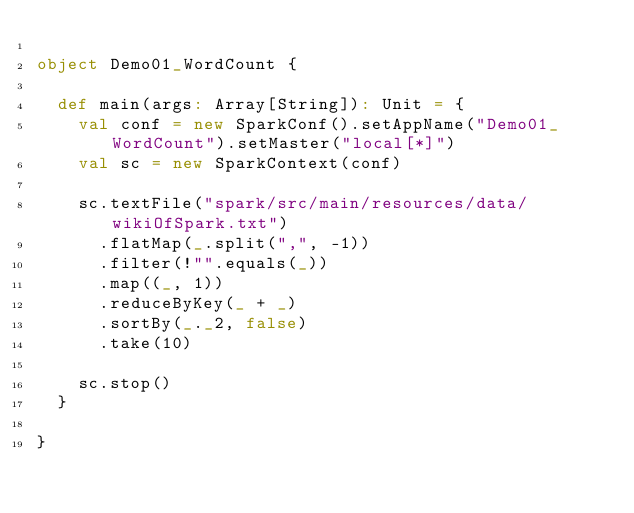<code> <loc_0><loc_0><loc_500><loc_500><_Scala_>
object Demo01_WordCount {

  def main(args: Array[String]): Unit = {
    val conf = new SparkConf().setAppName("Demo01_WordCount").setMaster("local[*]")
    val sc = new SparkContext(conf)

    sc.textFile("spark/src/main/resources/data/wikiOfSpark.txt")
      .flatMap(_.split(",", -1))
      .filter(!"".equals(_))
      .map((_, 1))
      .reduceByKey(_ + _)
      .sortBy(_._2, false)
      .take(10)

    sc.stop()
  }

}
</code> 